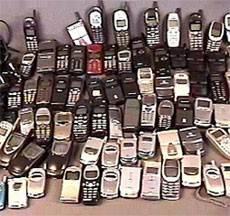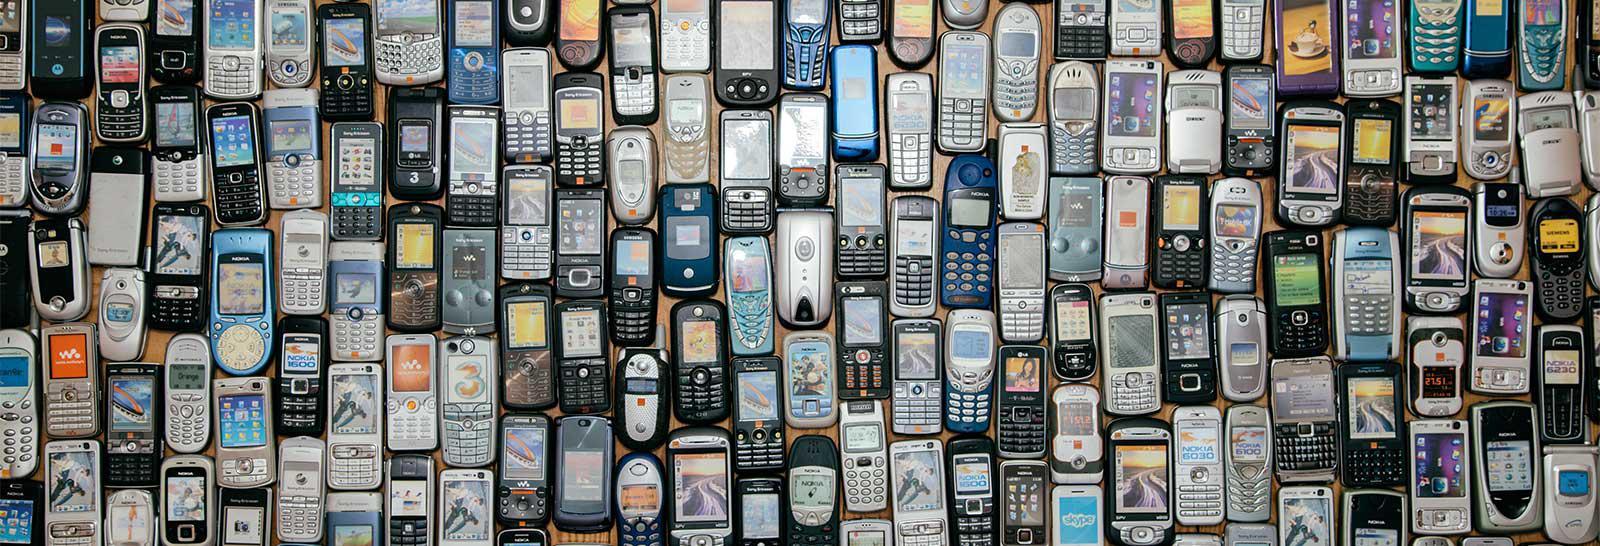The first image is the image on the left, the second image is the image on the right. Considering the images on both sides, is "In both images there are many mobile phones from a variety of brands and models." valid? Answer yes or no. Yes. The first image is the image on the left, the second image is the image on the right. Analyze the images presented: Is the assertion "A large assortment of cell phones are seen in both images." valid? Answer yes or no. Yes. 